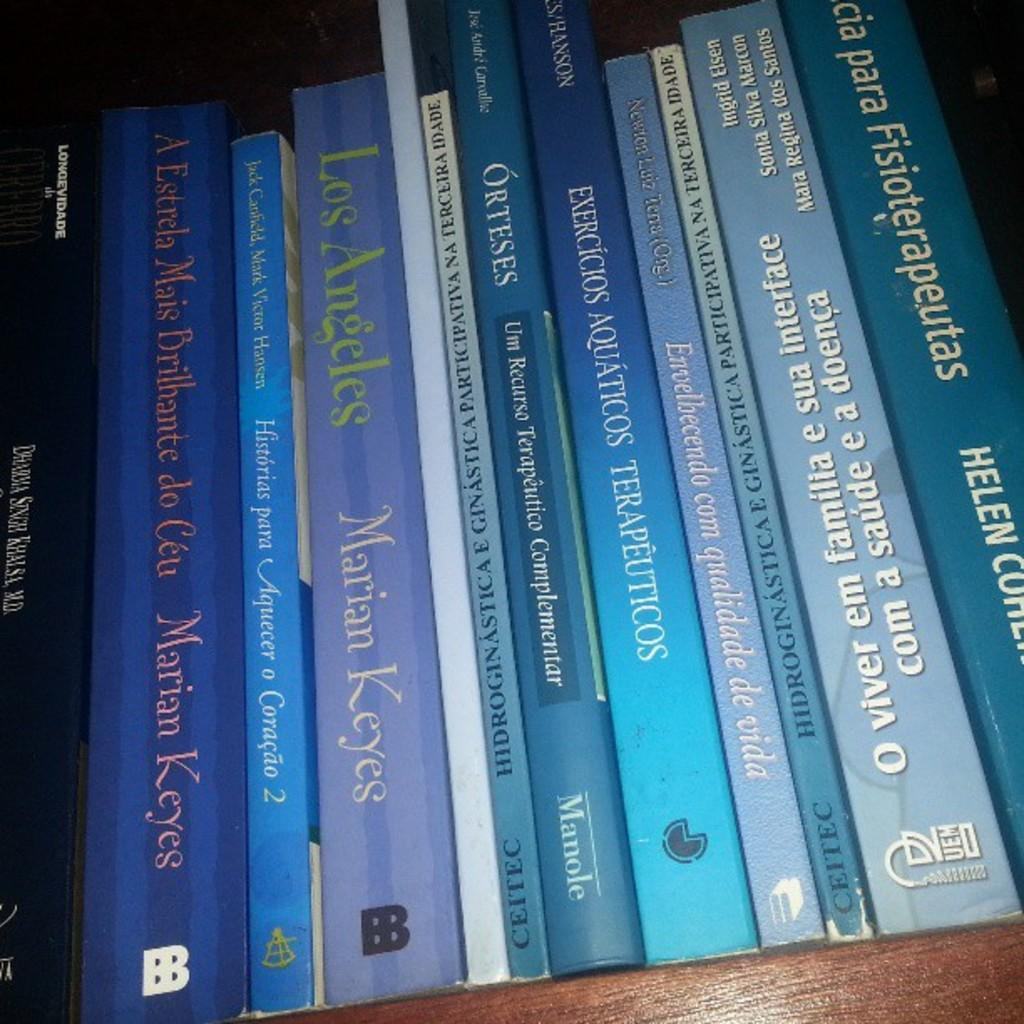<image>
Render a clear and concise summary of the photo. A stack of books on a shelf which includes a book about Los Angeles by Marian Keyes. 